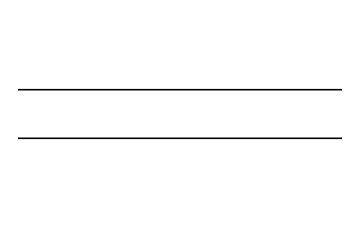What is the name of this chemical? The SMILES representation "C=C" corresponds to ethylene, which is the simple alkene with the formula C2H4. The double bond between the two carbon atoms characterizes it as ethylene.
Answer: ethylene How many carbon atoms are in this molecule? The SMILES "C=C" indicates there are two carbon atoms involved in the double bond between them. Counting the 'C' symbols confirms that there are two carbons.
Answer: two How many hydrogen atoms are bonded in total? In ethylene (C2H4), each carbon is bonded to two hydrogen atoms, leading to a total of four hydrogen atoms (2 carbons x 2 hydrogens). Thus, counting the bonds reveals all four hydrogens bonded to the two carbon atoms.
Answer: four What type of bond exists between the carbon atoms? The presence of "=" in the SMILES notation indicates a double bond; therefore, there is a double bond between the two carbon atoms in the ethylene molecule.
Answer: double bond Is this a saturated or unsaturated hydrocarbon? Ethylene has a double bond between its carbon atoms. Saturated hydrocarbons have only single bonds, while unsaturated hydrocarbons contain at least one double or triple bond. Hence, ethylene is classified as an unsaturated hydrocarbon due to its double bond.
Answer: unsaturated How many total bonds are present in the molecule? The molecule consists of one double bond between the two carbon atoms and four single bonds connecting to the four hydrogen atoms. Therefore, the total bond count is 1 (double bond) + 4 (single bonds) = 5 bonds overall.
Answer: five 